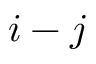Convert formula to latex. <formula><loc_0><loc_0><loc_500><loc_500>i - j</formula> 